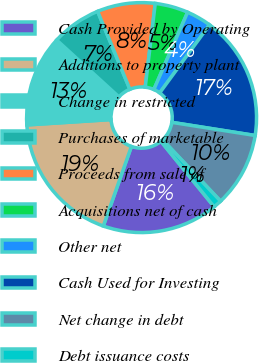Convert chart. <chart><loc_0><loc_0><loc_500><loc_500><pie_chart><fcel>Cash Provided by Operating<fcel>Additions to property plant<fcel>Change in restricted<fcel>Purchases of marketable<fcel>Proceeds from sale of<fcel>Acquisitions net of cash<fcel>Other net<fcel>Cash Used for Investing<fcel>Net change in debt<fcel>Debt issuance costs<nl><fcel>16.27%<fcel>18.59%<fcel>12.79%<fcel>6.98%<fcel>8.14%<fcel>4.66%<fcel>3.5%<fcel>17.43%<fcel>10.46%<fcel>1.18%<nl></chart> 